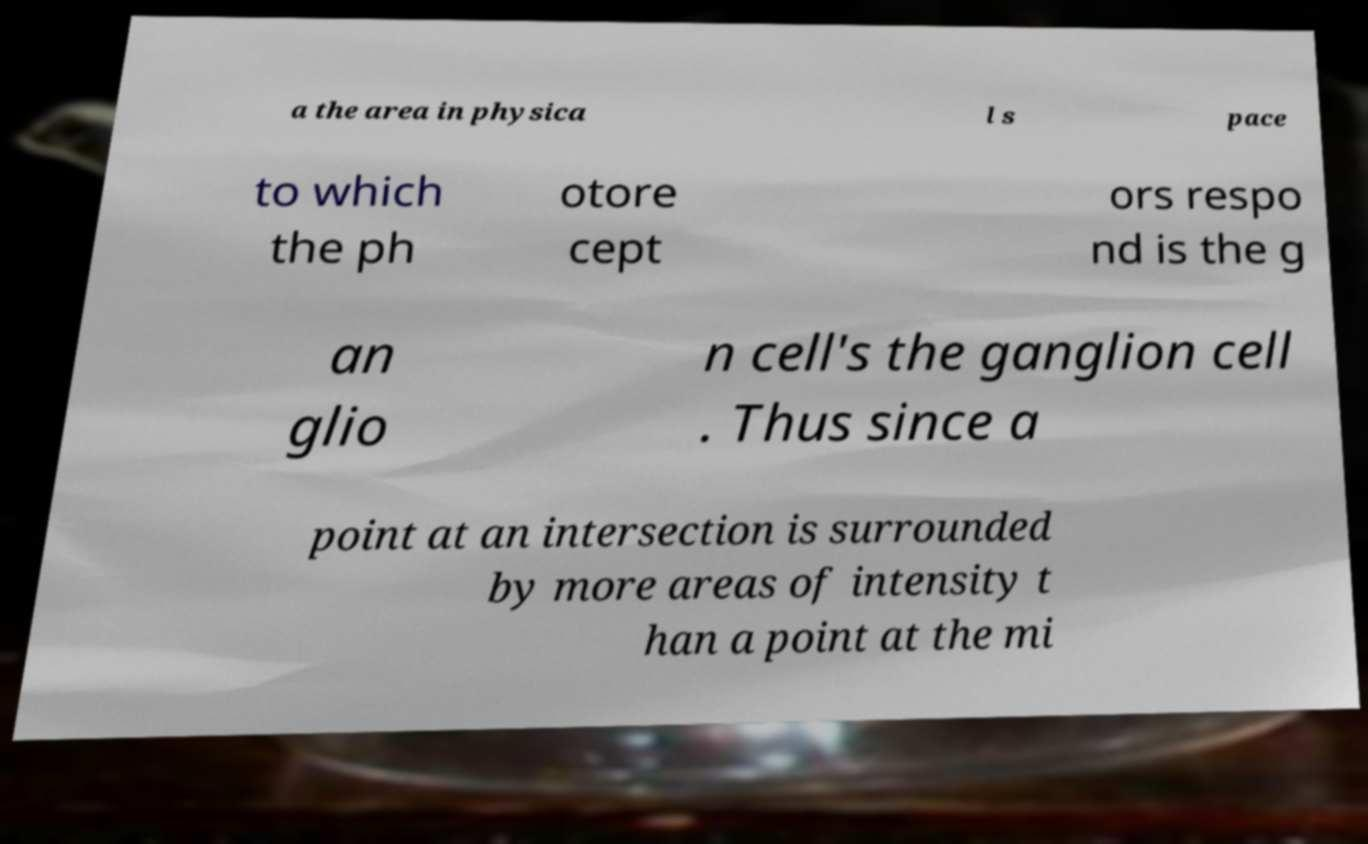There's text embedded in this image that I need extracted. Can you transcribe it verbatim? a the area in physica l s pace to which the ph otore cept ors respo nd is the g an glio n cell's the ganglion cell . Thus since a point at an intersection is surrounded by more areas of intensity t han a point at the mi 